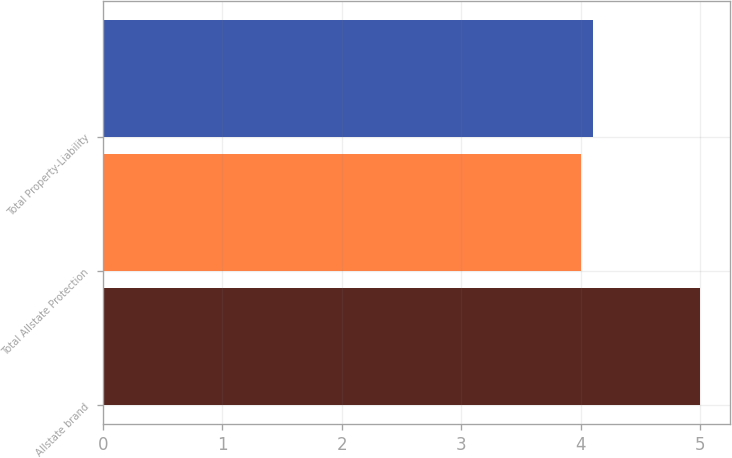<chart> <loc_0><loc_0><loc_500><loc_500><bar_chart><fcel>Allstate brand<fcel>Total Allstate Protection<fcel>Total Property-Liability<nl><fcel>5<fcel>4<fcel>4.1<nl></chart> 